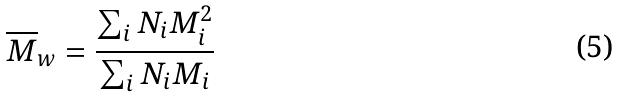Convert formula to latex. <formula><loc_0><loc_0><loc_500><loc_500>\overline { M } _ { w } = \frac { \sum _ { i } N _ { i } M _ { i } ^ { 2 } } { \sum _ { i } N _ { i } M _ { i } }</formula> 